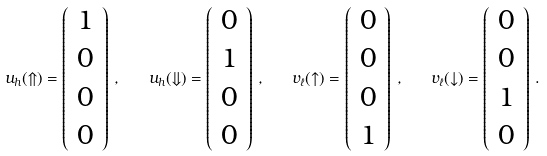<formula> <loc_0><loc_0><loc_500><loc_500>u _ { h } ( \Uparrow ) = \left ( \begin{array} { c } { 1 } \\ { 0 } \\ { 0 } \\ { 0 } \end{array} \right ) \, , \quad u _ { h } ( \Downarrow ) = \left ( \begin{array} { c } { 0 } \\ { 1 } \\ { 0 } \\ { 0 } \end{array} \right ) \, , \quad v _ { \ell } ( \uparrow ) = \left ( \begin{array} { c } { 0 } \\ { 0 } \\ { 0 } \\ { 1 } \end{array} \right ) \, , \quad v _ { \ell } ( \downarrow ) = \left ( \begin{array} { c } { 0 } \\ { 0 } \\ { 1 } \\ { 0 } \end{array} \right ) \, .</formula> 